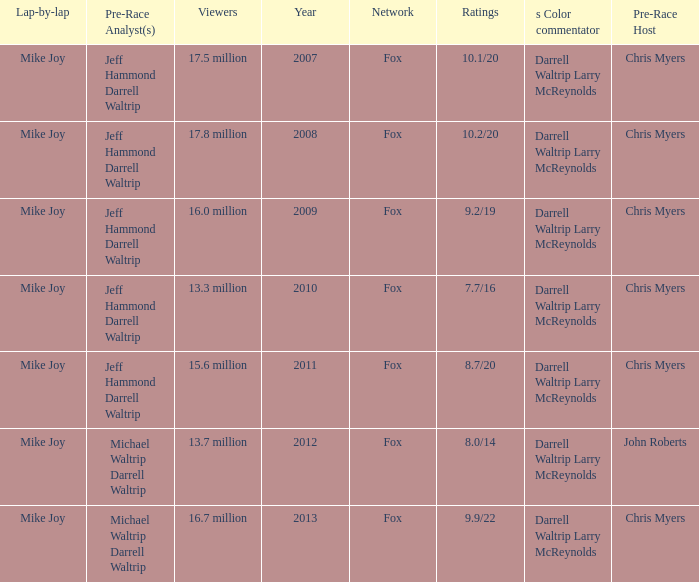Which Network has 16.0 million Viewers? Fox. 